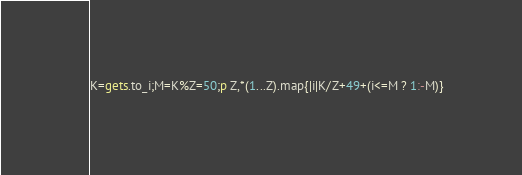Convert code to text. <code><loc_0><loc_0><loc_500><loc_500><_Ruby_>K=gets.to_i;M=K%Z=50;p Z,*(1...Z).map{|i|K/Z+49+(i<=M ? 1:-M)}</code> 